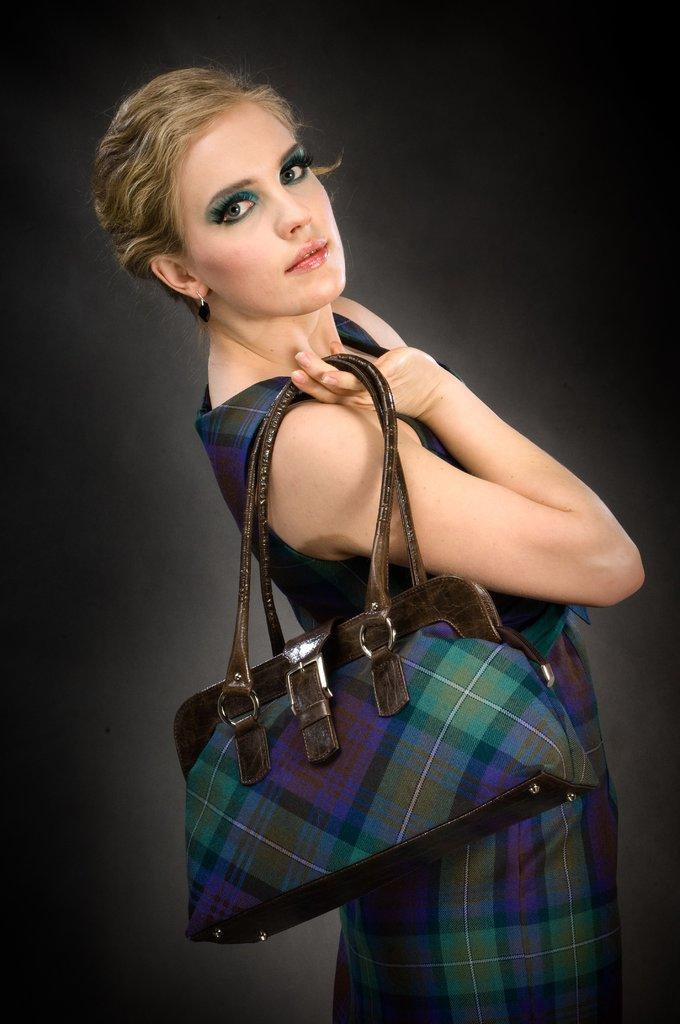What is the main subject of the image? The main subject of the image is a woman. What is the woman holding in her hand? The woman is holding a handbag in her hand. What type of brick is being used to construct the handbag in the image? There is no brick present in the image, as the woman is holding a handbag, not a brick. 